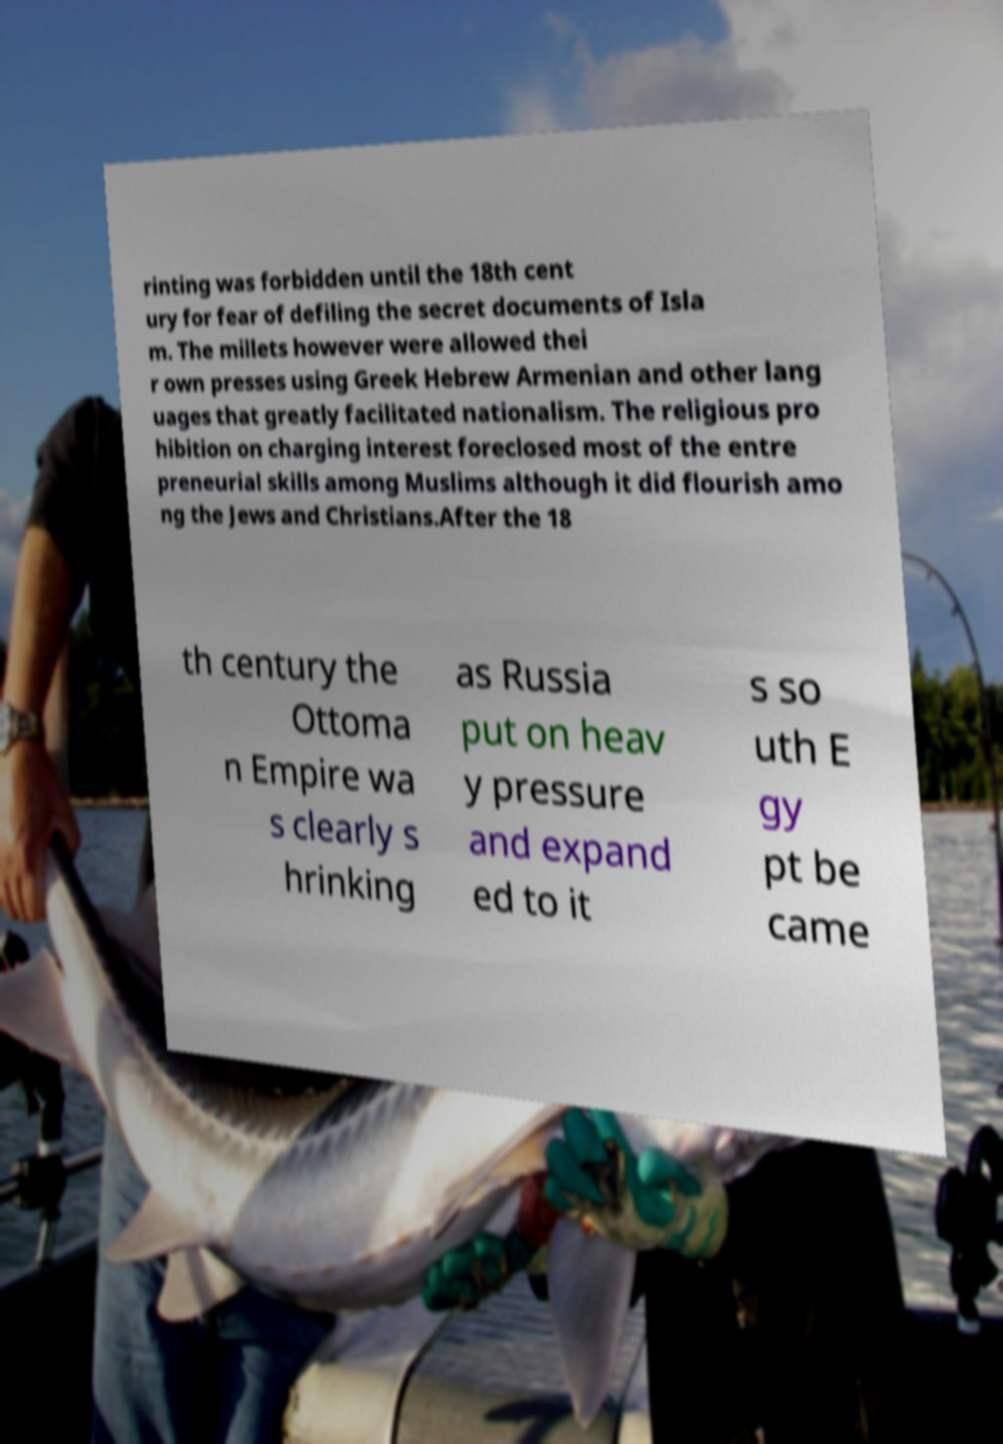Could you assist in decoding the text presented in this image and type it out clearly? rinting was forbidden until the 18th cent ury for fear of defiling the secret documents of Isla m. The millets however were allowed thei r own presses using Greek Hebrew Armenian and other lang uages that greatly facilitated nationalism. The religious pro hibition on charging interest foreclosed most of the entre preneurial skills among Muslims although it did flourish amo ng the Jews and Christians.After the 18 th century the Ottoma n Empire wa s clearly s hrinking as Russia put on heav y pressure and expand ed to it s so uth E gy pt be came 